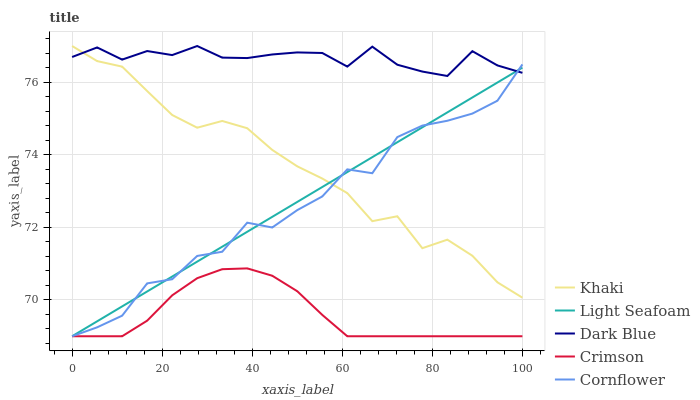Does Crimson have the minimum area under the curve?
Answer yes or no. Yes. Does Dark Blue have the maximum area under the curve?
Answer yes or no. Yes. Does Khaki have the minimum area under the curve?
Answer yes or no. No. Does Khaki have the maximum area under the curve?
Answer yes or no. No. Is Light Seafoam the smoothest?
Answer yes or no. Yes. Is Cornflower the roughest?
Answer yes or no. Yes. Is Dark Blue the smoothest?
Answer yes or no. No. Is Dark Blue the roughest?
Answer yes or no. No. Does Khaki have the lowest value?
Answer yes or no. No. Does Light Seafoam have the highest value?
Answer yes or no. No. Is Crimson less than Dark Blue?
Answer yes or no. Yes. Is Khaki greater than Crimson?
Answer yes or no. Yes. Does Crimson intersect Dark Blue?
Answer yes or no. No. 